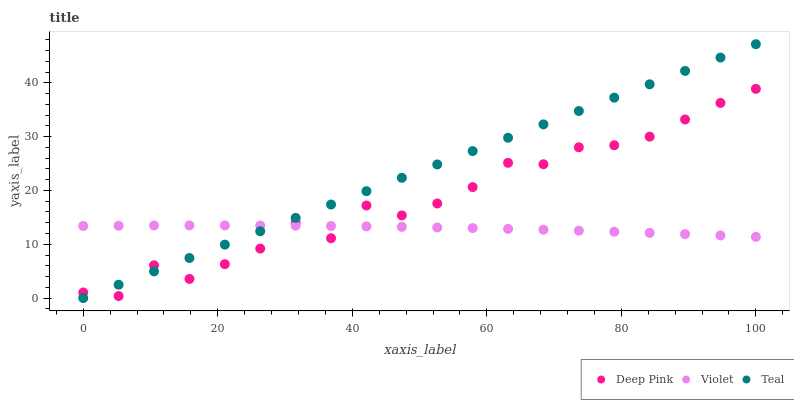Does Violet have the minimum area under the curve?
Answer yes or no. Yes. Does Teal have the maximum area under the curve?
Answer yes or no. Yes. Does Teal have the minimum area under the curve?
Answer yes or no. No. Does Violet have the maximum area under the curve?
Answer yes or no. No. Is Teal the smoothest?
Answer yes or no. Yes. Is Deep Pink the roughest?
Answer yes or no. Yes. Is Violet the smoothest?
Answer yes or no. No. Is Violet the roughest?
Answer yes or no. No. Does Teal have the lowest value?
Answer yes or no. Yes. Does Violet have the lowest value?
Answer yes or no. No. Does Teal have the highest value?
Answer yes or no. Yes. Does Violet have the highest value?
Answer yes or no. No. Does Teal intersect Deep Pink?
Answer yes or no. Yes. Is Teal less than Deep Pink?
Answer yes or no. No. Is Teal greater than Deep Pink?
Answer yes or no. No. 